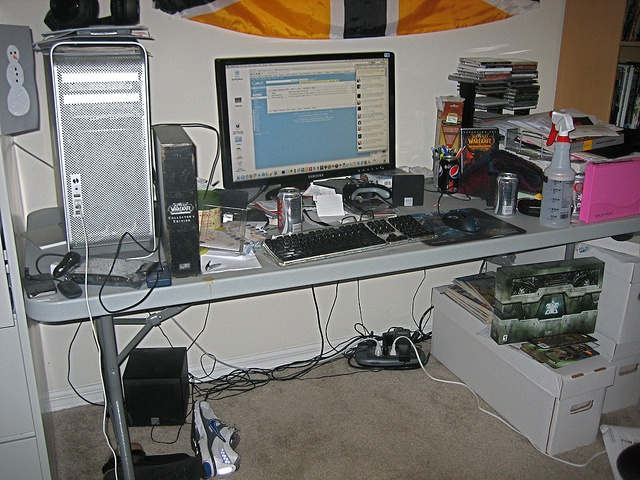Describe the objects in this image and their specific colors. I can see tv in gray, darkgray, and black tones, keyboard in gray, black, darkgray, and lightgray tones, bottle in gray tones, cup in gray, black, darkgray, and darkblue tones, and mouse in gray, black, and purple tones in this image. 